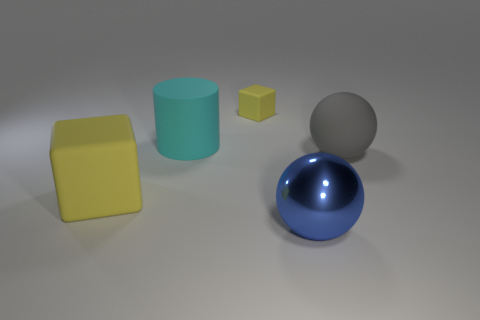Could you describe the lighting in the scene? The lighting in the scene is diffused and soft, with what appears to be a primary light source coming from the upper left, judging by the shadows. This creates gentle shadows to the right of the objects, providing a sense of depth and making the objects appear grounded. The light source is likely simulating an environment with ambient light, such as an overcast day or soft indoor lighting. 